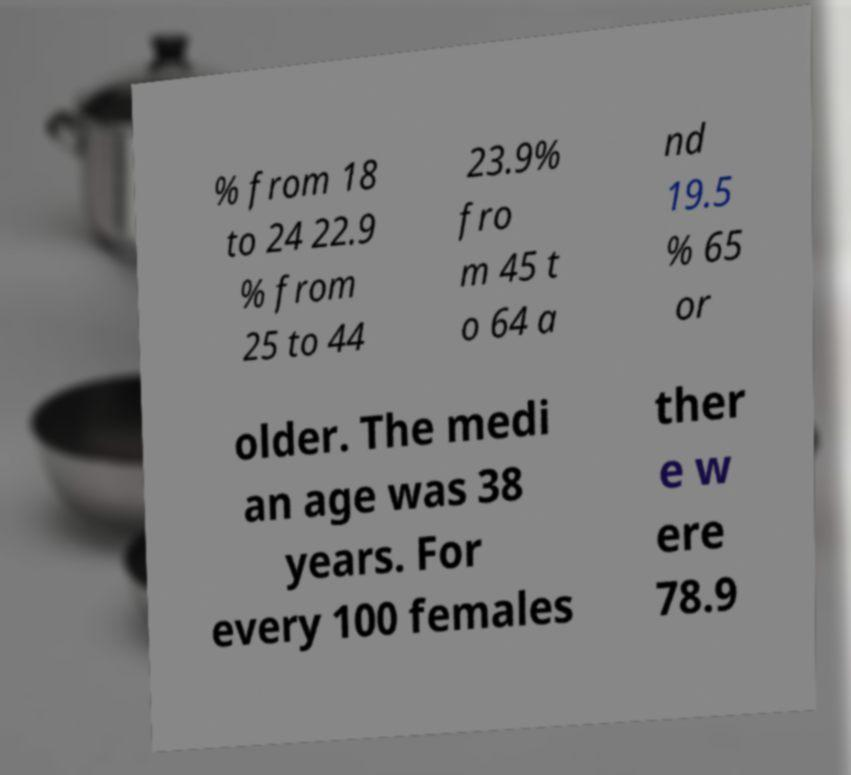I need the written content from this picture converted into text. Can you do that? % from 18 to 24 22.9 % from 25 to 44 23.9% fro m 45 t o 64 a nd 19.5 % 65 or older. The medi an age was 38 years. For every 100 females ther e w ere 78.9 